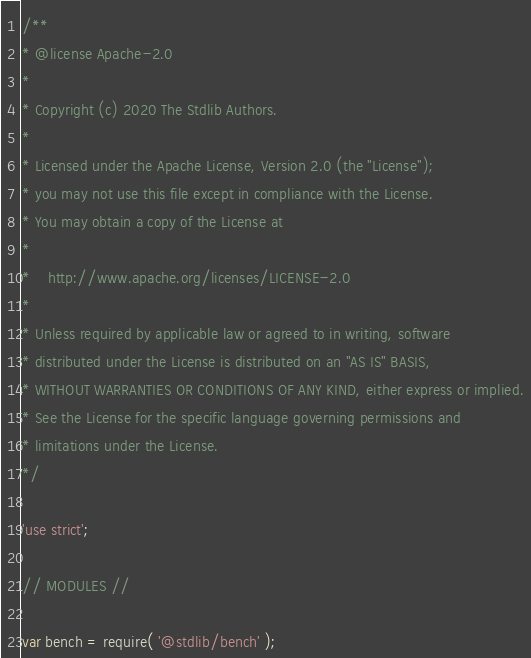<code> <loc_0><loc_0><loc_500><loc_500><_JavaScript_>/**
* @license Apache-2.0
*
* Copyright (c) 2020 The Stdlib Authors.
*
* Licensed under the Apache License, Version 2.0 (the "License");
* you may not use this file except in compliance with the License.
* You may obtain a copy of the License at
*
*    http://www.apache.org/licenses/LICENSE-2.0
*
* Unless required by applicable law or agreed to in writing, software
* distributed under the License is distributed on an "AS IS" BASIS,
* WITHOUT WARRANTIES OR CONDITIONS OF ANY KIND, either express or implied.
* See the License for the specific language governing permissions and
* limitations under the License.
*/

'use strict';

// MODULES //

var bench = require( '@stdlib/bench' );</code> 